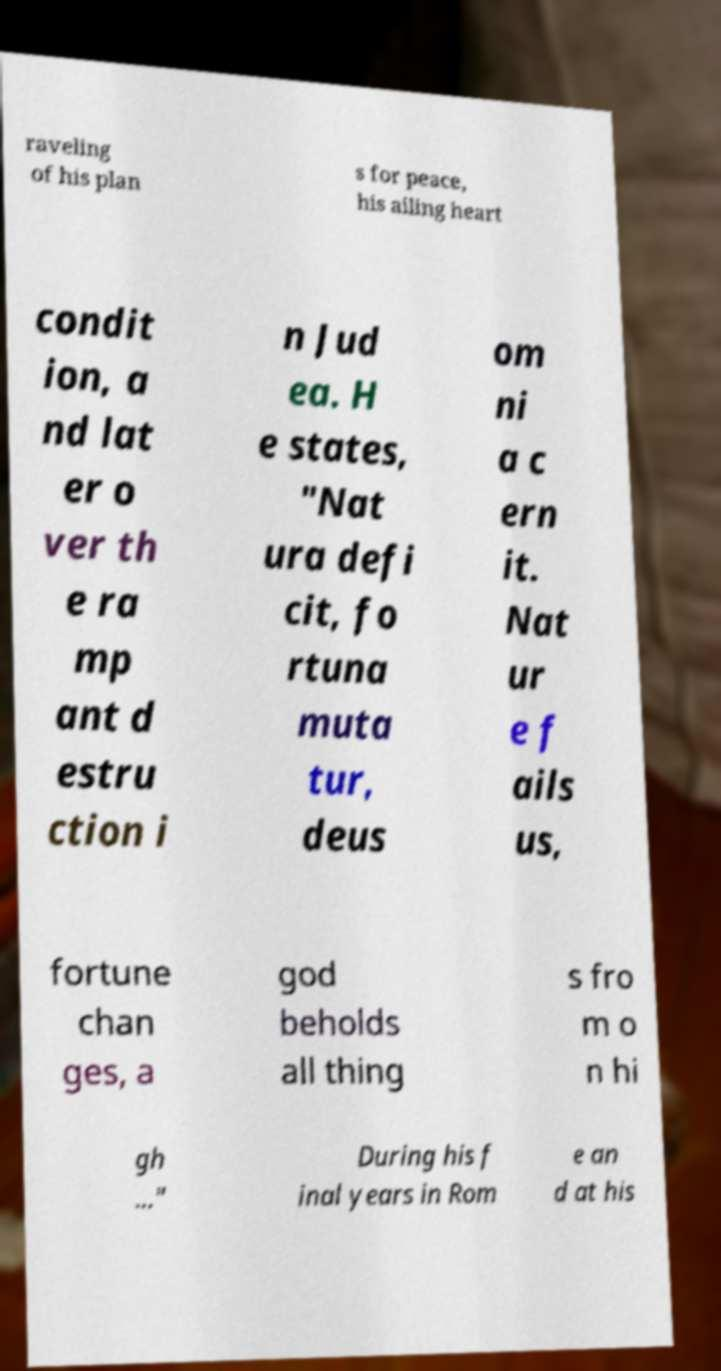I need the written content from this picture converted into text. Can you do that? raveling of his plan s for peace, his ailing heart condit ion, a nd lat er o ver th e ra mp ant d estru ction i n Jud ea. H e states, "Nat ura defi cit, fo rtuna muta tur, deus om ni a c ern it. Nat ur e f ails us, fortune chan ges, a god beholds all thing s fro m o n hi gh …" During his f inal years in Rom e an d at his 